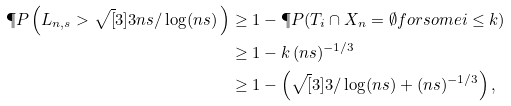Convert formula to latex. <formula><loc_0><loc_0><loc_500><loc_500>\P P \left ( L _ { n , s } > \sqrt { [ } 3 ] { 3 n s / \log ( n s ) } \, \right ) & \geq 1 - \P P ( T _ { i } \cap X _ { n } = \emptyset f o r s o m e i \leq k ) \\ & \geq 1 - k \, ( n s ) ^ { - 1 / 3 } \\ & \geq 1 - \left ( \sqrt { [ } 3 ] { 3 / \log ( n s ) } + ( n s ) ^ { - 1 / 3 } \right ) ,</formula> 